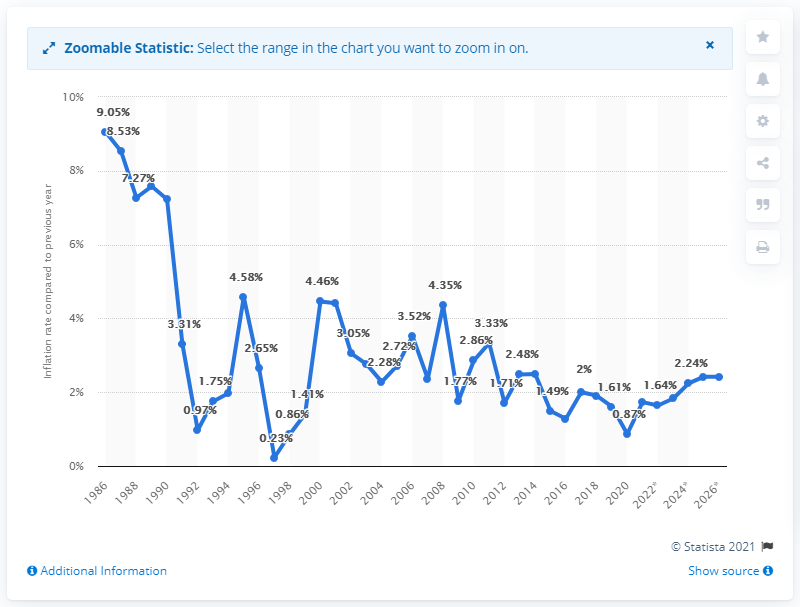Draw attention to some important aspects in this diagram. In 2020, the inflation rate in Australia was 0.87%. 